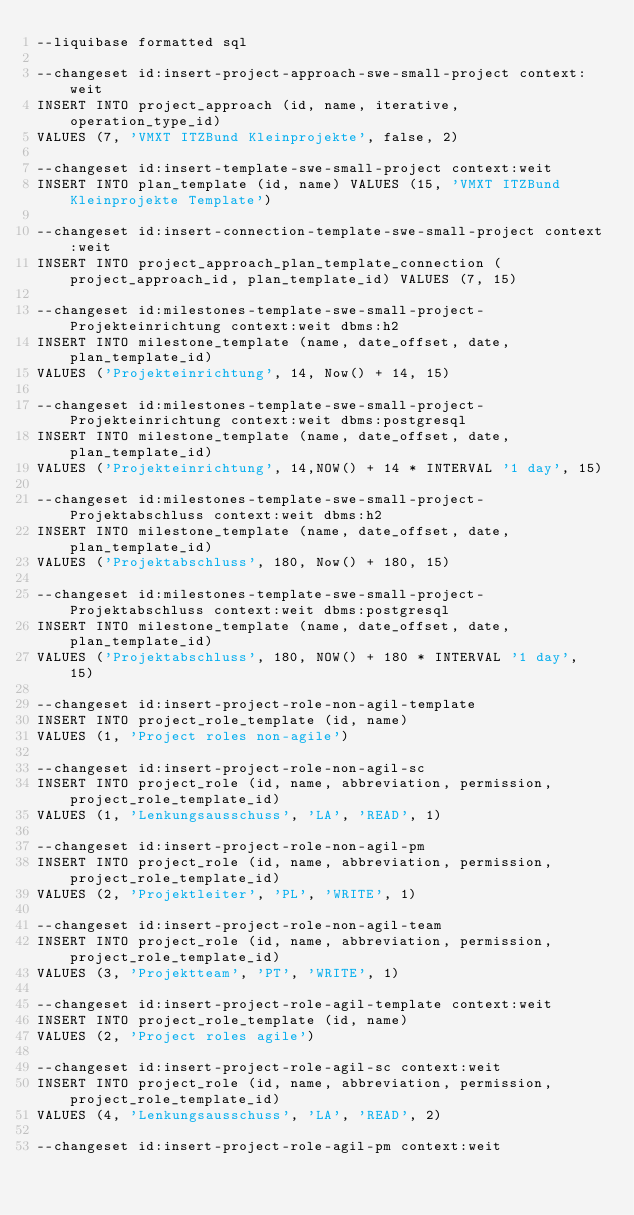<code> <loc_0><loc_0><loc_500><loc_500><_SQL_>--liquibase formatted sql

--changeset id:insert-project-approach-swe-small-project context:weit
INSERT INTO project_approach (id, name, iterative, operation_type_id)
VALUES (7, 'VMXT ITZBund Kleinprojekte', false, 2)

--changeset id:insert-template-swe-small-project context:weit
INSERT INTO plan_template (id, name) VALUES (15, 'VMXT ITZBund Kleinprojekte Template')

--changeset id:insert-connection-template-swe-small-project context:weit
INSERT INTO project_approach_plan_template_connection (project_approach_id, plan_template_id) VALUES (7, 15)

--changeset id:milestones-template-swe-small-project-Projekteinrichtung context:weit dbms:h2
INSERT INTO milestone_template (name, date_offset, date, plan_template_id)
VALUES ('Projekteinrichtung', 14, Now() + 14, 15)

--changeset id:milestones-template-swe-small-project-Projekteinrichtung context:weit dbms:postgresql
INSERT INTO milestone_template (name, date_offset, date, plan_template_id)
VALUES ('Projekteinrichtung', 14,NOW() + 14 * INTERVAL '1 day', 15)

--changeset id:milestones-template-swe-small-project-Projektabschluss context:weit dbms:h2
INSERT INTO milestone_template (name, date_offset, date, plan_template_id)
VALUES ('Projektabschluss', 180, Now() + 180, 15)

--changeset id:milestones-template-swe-small-project-Projektabschluss context:weit dbms:postgresql
INSERT INTO milestone_template (name, date_offset, date, plan_template_id)
VALUES ('Projektabschluss', 180, NOW() + 180 * INTERVAL '1 day', 15)

--changeset id:insert-project-role-non-agil-template
INSERT INTO project_role_template (id, name)
VALUES (1, 'Project roles non-agile')

--changeset id:insert-project-role-non-agil-sc
INSERT INTO project_role (id, name, abbreviation, permission, project_role_template_id)
VALUES (1, 'Lenkungsausschuss', 'LA', 'READ', 1)

--changeset id:insert-project-role-non-agil-pm
INSERT INTO project_role (id, name, abbreviation, permission, project_role_template_id)
VALUES (2, 'Projektleiter', 'PL', 'WRITE', 1)

--changeset id:insert-project-role-non-agil-team
INSERT INTO project_role (id, name, abbreviation, permission, project_role_template_id)
VALUES (3, 'Projektteam', 'PT', 'WRITE', 1)

--changeset id:insert-project-role-agil-template context:weit
INSERT INTO project_role_template (id, name)
VALUES (2, 'Project roles agile')

--changeset id:insert-project-role-agil-sc context:weit
INSERT INTO project_role (id, name, abbreviation, permission, project_role_template_id)
VALUES (4, 'Lenkungsausschuss', 'LA', 'READ', 2)

--changeset id:insert-project-role-agil-pm context:weit</code> 